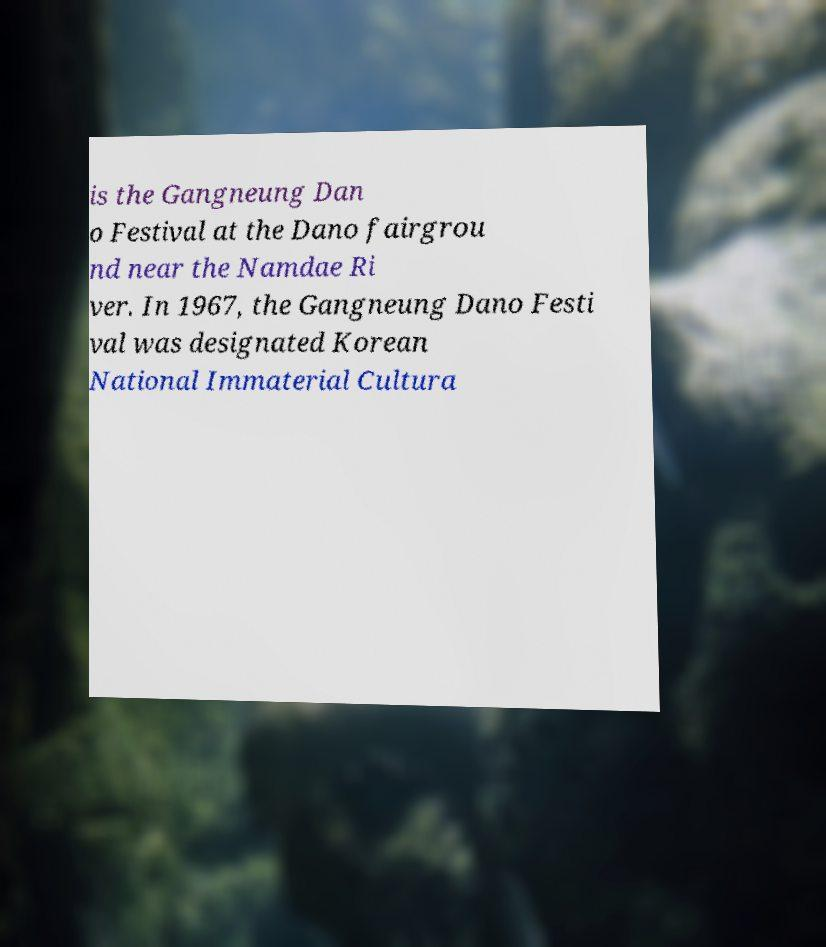There's text embedded in this image that I need extracted. Can you transcribe it verbatim? is the Gangneung Dan o Festival at the Dano fairgrou nd near the Namdae Ri ver. In 1967, the Gangneung Dano Festi val was designated Korean National Immaterial Cultura 